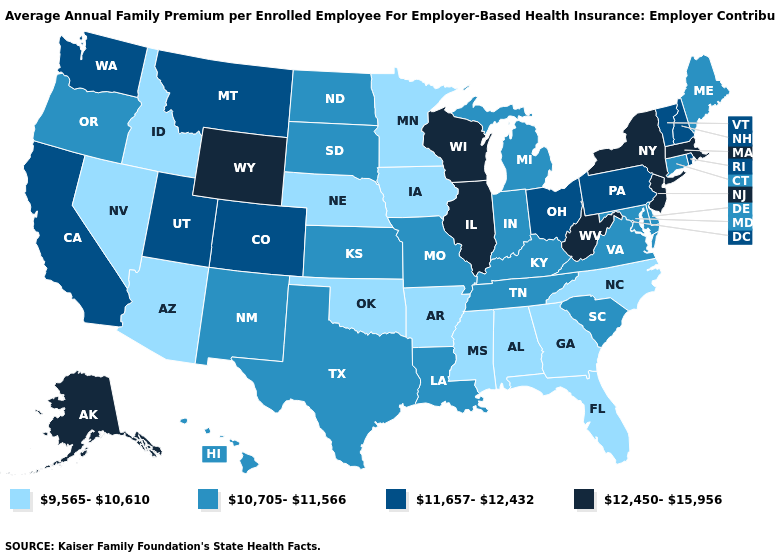Does Massachusetts have the highest value in the Northeast?
Give a very brief answer. Yes. Among the states that border Idaho , which have the lowest value?
Quick response, please. Nevada. What is the value of North Carolina?
Concise answer only. 9,565-10,610. Which states hav the highest value in the MidWest?
Keep it brief. Illinois, Wisconsin. What is the value of New Hampshire?
Keep it brief. 11,657-12,432. Does Delaware have the lowest value in the USA?
Quick response, please. No. What is the value of Washington?
Be succinct. 11,657-12,432. Does the map have missing data?
Write a very short answer. No. What is the value of Idaho?
Answer briefly. 9,565-10,610. Does Alabama have a lower value than Florida?
Concise answer only. No. Does Wyoming have the lowest value in the USA?
Be succinct. No. What is the lowest value in the West?
Give a very brief answer. 9,565-10,610. What is the value of Maine?
Give a very brief answer. 10,705-11,566. How many symbols are there in the legend?
Write a very short answer. 4. Name the states that have a value in the range 9,565-10,610?
Keep it brief. Alabama, Arizona, Arkansas, Florida, Georgia, Idaho, Iowa, Minnesota, Mississippi, Nebraska, Nevada, North Carolina, Oklahoma. 